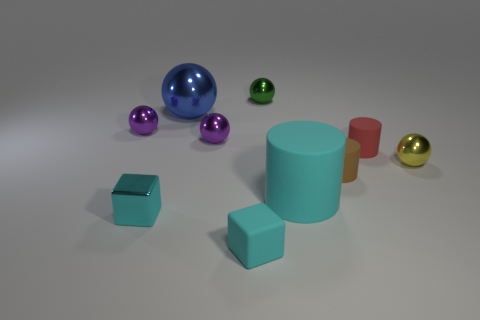There is a small rubber thing that is left of the large cyan rubber cylinder; what is its shape?
Your response must be concise. Cube. What number of small cyan spheres are the same material as the yellow sphere?
Offer a terse response. 0. Is the number of purple balls on the right side of the tiny brown object less than the number of tiny metal spheres?
Keep it short and to the point. Yes. How big is the metal object that is in front of the small metallic thing right of the red matte cylinder?
Keep it short and to the point. Small. There is a big rubber cylinder; is it the same color as the small shiny object in front of the tiny yellow metallic sphere?
Give a very brief answer. Yes. There is a green object that is the same size as the cyan shiny thing; what material is it?
Offer a terse response. Metal. Are there fewer small green spheres on the left side of the tiny yellow metallic ball than small spheres that are right of the tiny cyan rubber block?
Your answer should be very brief. Yes. There is a tiny matte thing that is in front of the metallic thing in front of the brown cylinder; what is its shape?
Your answer should be very brief. Cube. Are any big green matte cylinders visible?
Keep it short and to the point. No. What color is the big object that is behind the small yellow shiny ball?
Your response must be concise. Blue. 